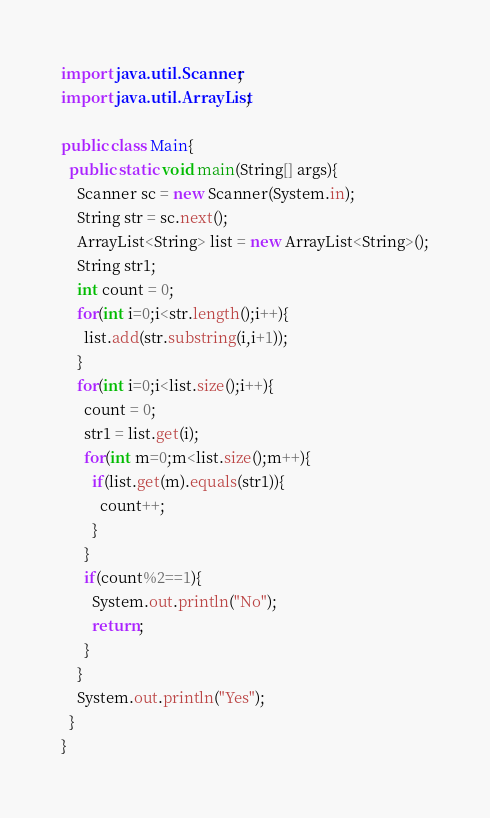<code> <loc_0><loc_0><loc_500><loc_500><_Java_>import java.util.Scanner;
import java.util.ArrayList;

public class Main{
  public static void main(String[] args){
    Scanner sc = new Scanner(System.in);
    String str = sc.next();
    ArrayList<String> list = new ArrayList<String>();
    String str1;
    int count = 0;
    for(int i=0;i<str.length();i++){
      list.add(str.substring(i,i+1));
    }
    for(int i=0;i<list.size();i++){
      count = 0;
      str1 = list.get(i);
      for(int m=0;m<list.size();m++){
        if(list.get(m).equals(str1)){
          count++;
        }
      }
      if(count%2==1){
        System.out.println("No");
        return;
      }
    }
    System.out.println("Yes");
  }
}</code> 